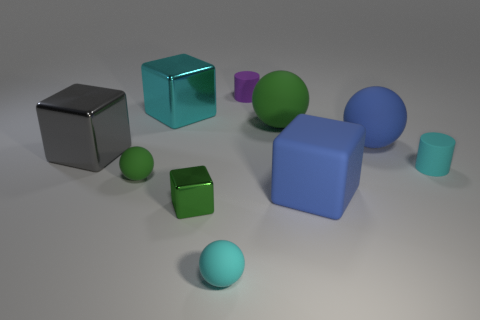Subtract 2 blocks. How many blocks are left? 2 Subtract all gray balls. Subtract all yellow cubes. How many balls are left? 4 Add 7 tiny green metallic things. How many tiny green metallic things are left? 8 Add 2 big red objects. How many big red objects exist? 2 Subtract 0 yellow cylinders. How many objects are left? 10 Subtract all blocks. How many objects are left? 6 Subtract all blue metal spheres. Subtract all blue rubber spheres. How many objects are left? 9 